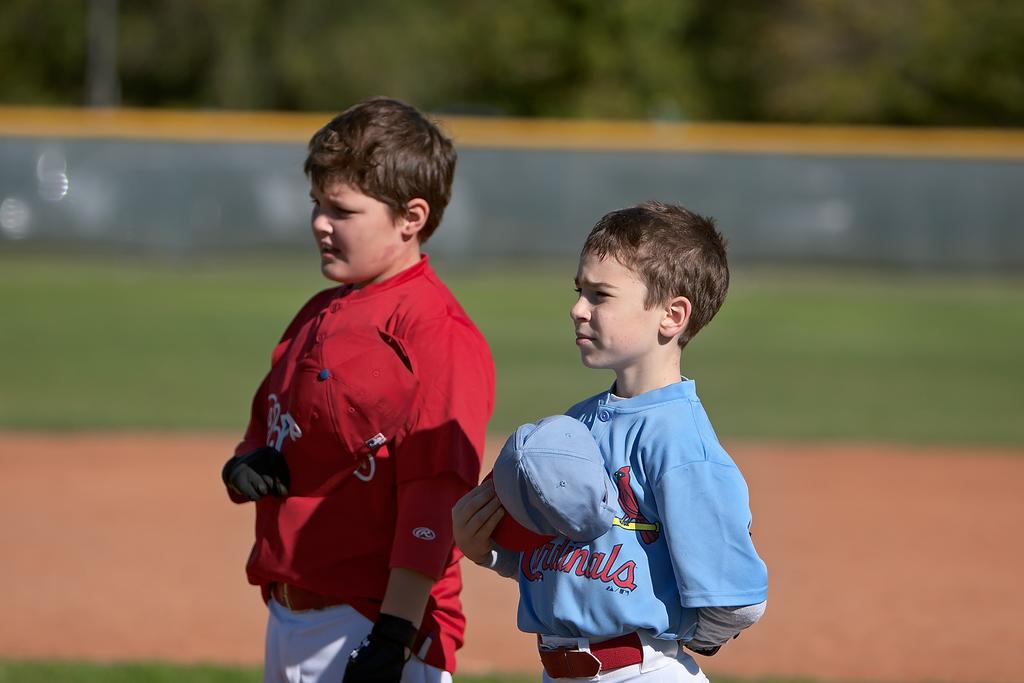<image>
Relay a brief, clear account of the picture shown. a little boy in a blue cardinals shirt next to a boy in a red shirt 